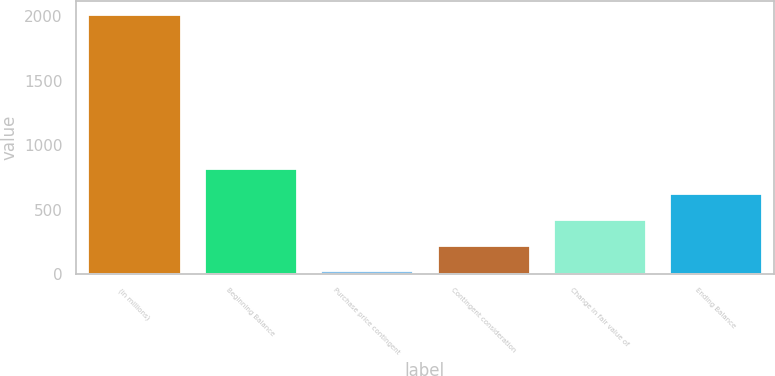<chart> <loc_0><loc_0><loc_500><loc_500><bar_chart><fcel>(in millions)<fcel>Beginning Balance<fcel>Purchase price contingent<fcel>Contingent consideration<fcel>Change in fair value of<fcel>Ending Balance<nl><fcel>2017<fcel>823.6<fcel>28<fcel>226.9<fcel>425.8<fcel>624.7<nl></chart> 